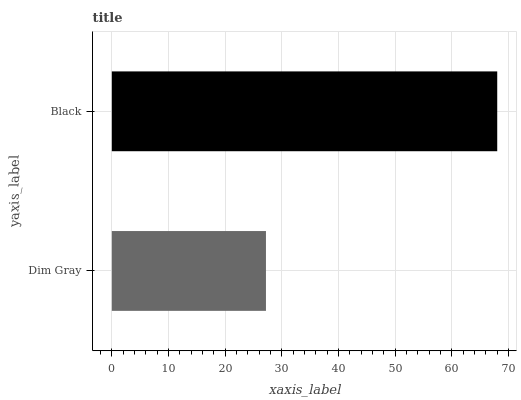Is Dim Gray the minimum?
Answer yes or no. Yes. Is Black the maximum?
Answer yes or no. Yes. Is Black the minimum?
Answer yes or no. No. Is Black greater than Dim Gray?
Answer yes or no. Yes. Is Dim Gray less than Black?
Answer yes or no. Yes. Is Dim Gray greater than Black?
Answer yes or no. No. Is Black less than Dim Gray?
Answer yes or no. No. Is Black the high median?
Answer yes or no. Yes. Is Dim Gray the low median?
Answer yes or no. Yes. Is Dim Gray the high median?
Answer yes or no. No. Is Black the low median?
Answer yes or no. No. 